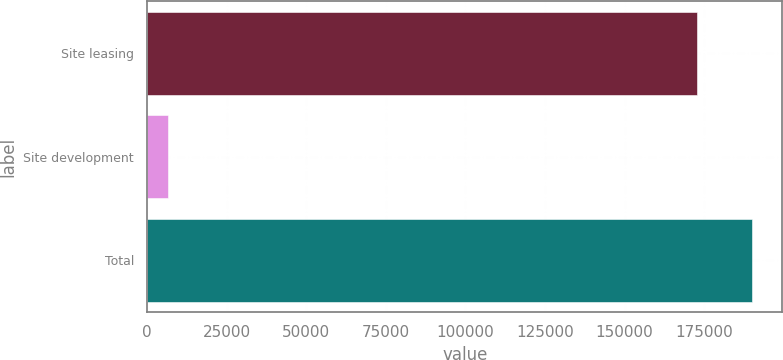Convert chart to OTSL. <chart><loc_0><loc_0><loc_500><loc_500><bar_chart><fcel>Site leasing<fcel>Site development<fcel>Total<nl><fcel>172765<fcel>6563<fcel>190042<nl></chart> 